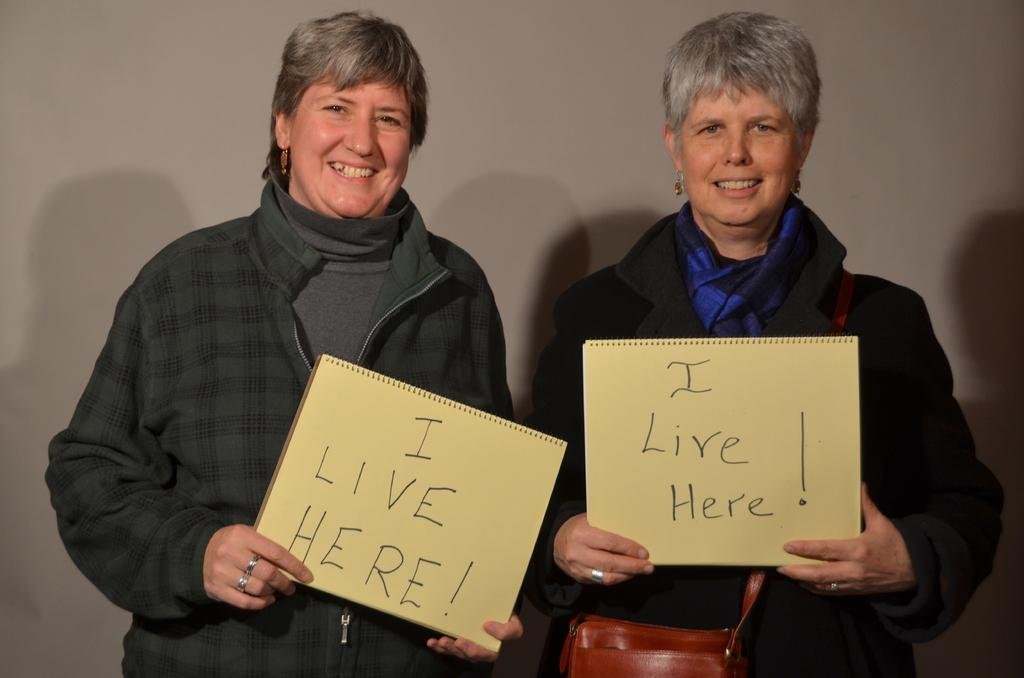How many people are in the image? There are two persons in the image. What are the persons wearing? Both persons are wearing black color sweaters. What are the persons holding in the image? The persons are holding a board. What does the writing on the board say? The board has writing on it that says "I live here." What type of stone is the dress made of in the image? There is no dress present in the image, and therefore no stone or material can be associated with it. 